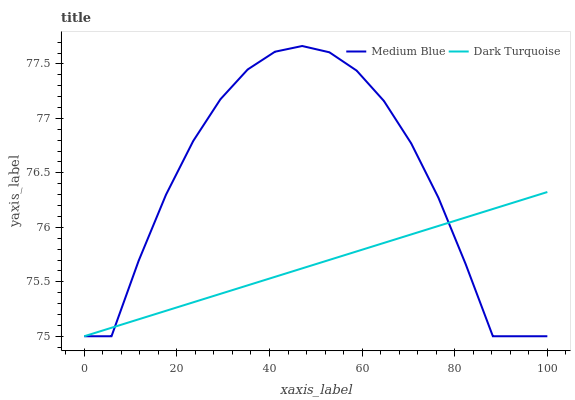Does Dark Turquoise have the minimum area under the curve?
Answer yes or no. Yes. Does Medium Blue have the maximum area under the curve?
Answer yes or no. Yes. Does Medium Blue have the minimum area under the curve?
Answer yes or no. No. Is Dark Turquoise the smoothest?
Answer yes or no. Yes. Is Medium Blue the roughest?
Answer yes or no. Yes. Is Medium Blue the smoothest?
Answer yes or no. No. Does Medium Blue have the highest value?
Answer yes or no. Yes. Does Dark Turquoise intersect Medium Blue?
Answer yes or no. Yes. Is Dark Turquoise less than Medium Blue?
Answer yes or no. No. Is Dark Turquoise greater than Medium Blue?
Answer yes or no. No. 